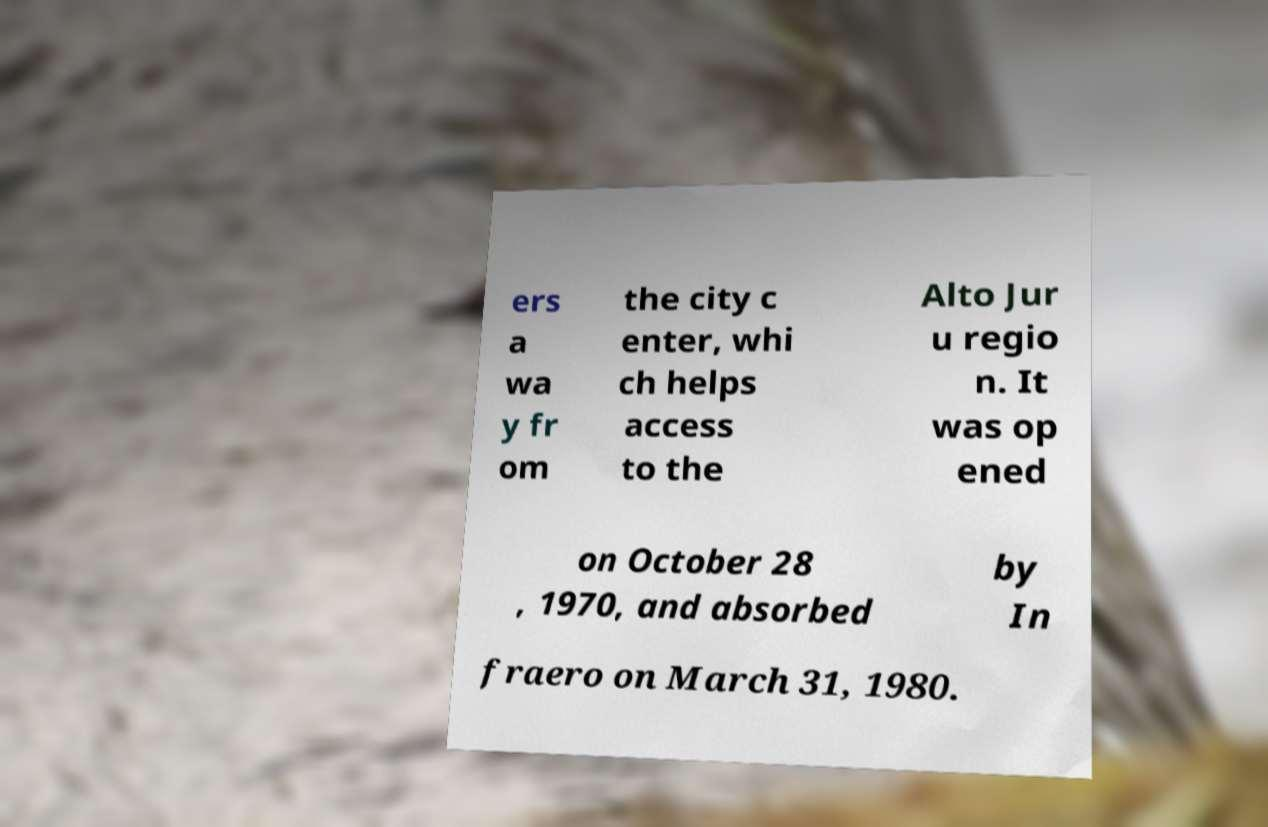Could you extract and type out the text from this image? ers a wa y fr om the city c enter, whi ch helps access to the Alto Jur u regio n. It was op ened on October 28 , 1970, and absorbed by In fraero on March 31, 1980. 